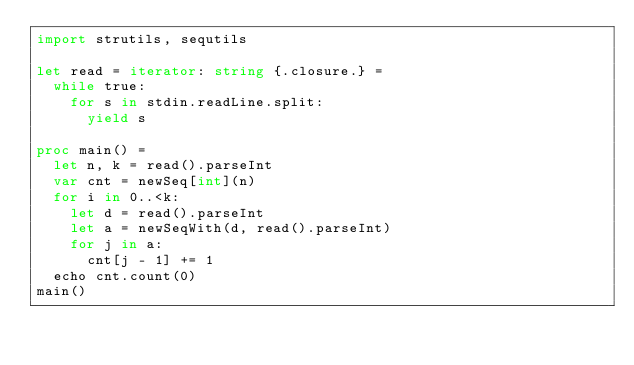<code> <loc_0><loc_0><loc_500><loc_500><_Nim_>import strutils, sequtils

let read = iterator: string {.closure.} =
  while true:
    for s in stdin.readLine.split:
      yield s

proc main() =
  let n, k = read().parseInt
  var cnt = newSeq[int](n)
  for i in 0..<k:
    let d = read().parseInt
    let a = newSeqWith(d, read().parseInt)
    for j in a:
      cnt[j - 1] += 1
  echo cnt.count(0)
main()</code> 